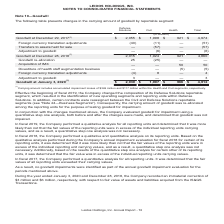According to Leidos Holdings's financial document, What was the result of composition change of Defense solutions? resulted in the identification of new operating segments and reporting units within Defense Solutions.. The document states: "of its Defense Solutions reportable segment, which resulted in the identification of new operating segments and reporting units within Defense Solutio..." Also, What was the immaterial correction in January 2020 and December 2018? The document shows two values: $3 million and $6 million. From the document: "ecorded an immaterial correction of $3 million and $6 million, respectively, with respect to fair value of assets and liabilities acquired from the IS..." Also, What was the Goodwill at December 29, 2017 under Defense Solutions, Civil and Health respectively? The document contains multiple relevant values: $2,055, $1,998, $921 (in millions). From the document: "odwill at December 29, 2017 (1) $ 2,055 $ 1,998 $ 921 $ 4,974 Foreign currency translation adjustments (40) (11) — (51) Transfers to assets held for s..." Additionally, In which category was Goodwill at December 29, 2017 under 2,000 million? The document shows two values: Civil and Health. Locate and analyze goodwill at december 29, 2017(1) in row 3. From the document: "Defense Solutions Civil Health Total Defense Solutions Civil Health Total..." Also, can you calculate: What was the average Foreign currency translation adjustments? To answer this question, I need to perform calculations using the financial data. The calculation is: -(40 + 11 + 0) / 3, which equals -17 (in millions). This is based on the information: "74 Foreign currency translation adjustments (40) (11) — (51) Transfers to assets held for sale — (57) — (57) Adjustment to goodwill — (6) — (6) Goodwill $ 4,974 Foreign currency translation adjustment..." The key data points involved are: 0, 11, 40. Also, can you calculate: What was the change between total Goodwill from 2018 to 2019? Based on the calculation: 4,974 - 4,860, the result is 114 (in millions). This is based on the information: "at December 29, 2017 (1) $ 2,055 $ 1,998 $ 921 $ 4,974 Foreign currency translation adjustments (40) (11) — (51) Transfers to assets held for sale — (57) Goodwill at December 28, 2018 (1) 2,015 1,924 ..." The key data points involved are: 4,860, 4,974. 